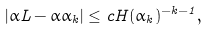<formula> <loc_0><loc_0><loc_500><loc_500>| \alpha L - \alpha \alpha _ { k } | \leq c H ( \alpha _ { k } ) ^ { - k - 1 } ,</formula> 